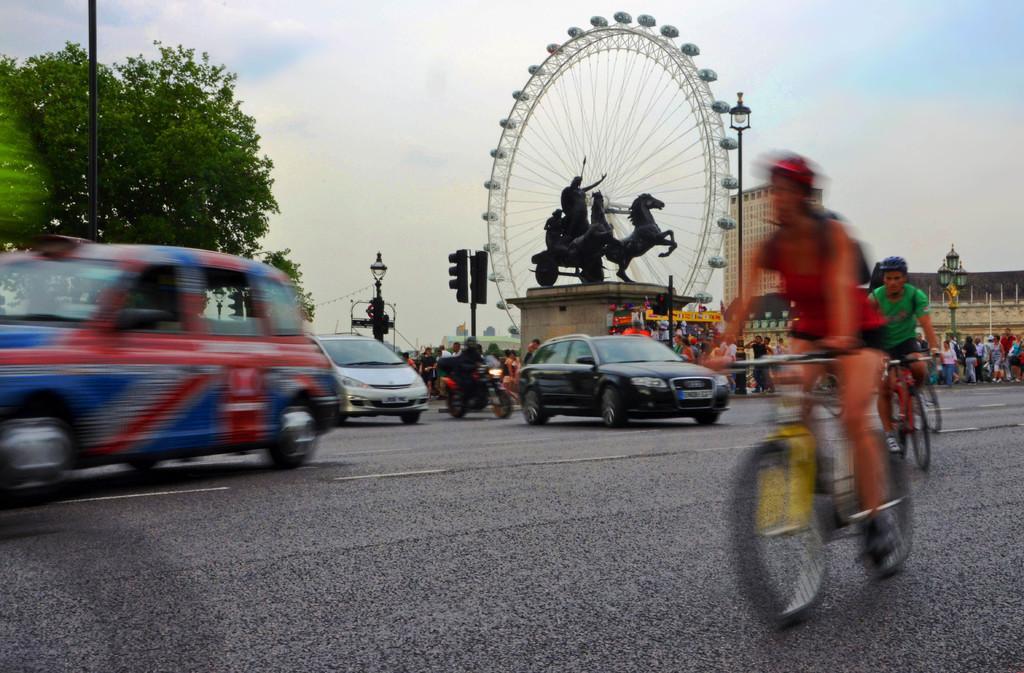In one or two sentences, can you explain what this image depicts? vehicles are moving the road. people are riding bicycles. behind them people are standing. at the center there is a statue of the horse. behind that there is a giant wheel. at the left back there is a tree and at the right back there is a building. 